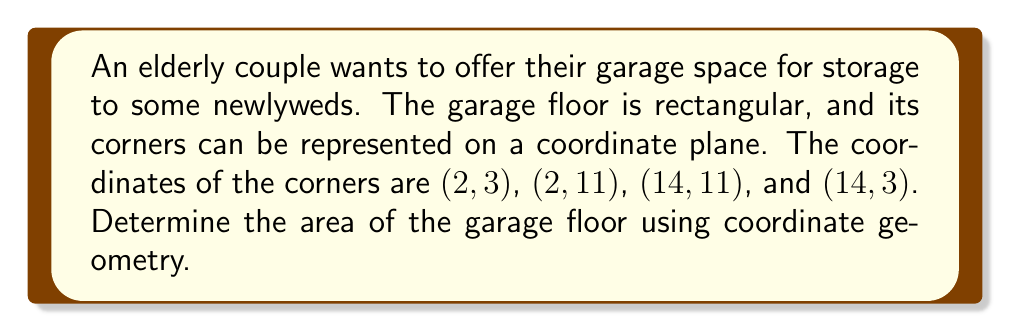Teach me how to tackle this problem. To solve this problem, we'll follow these steps:

1) First, we need to identify the length and width of the rectangle using the given coordinates.

2) The length of the rectangle is the distance between points with different x-coordinates:
   $$(14 - 2) = 12$$

3) The width of the rectangle is the distance between points with different y-coordinates:
   $$(11 - 3) = 8$$

4) We can visualize this using the following diagram:

[asy]
unitsize(0.5cm);
draw((2,3)--(14,3)--(14,11)--(2,11)--cycle);
label("(2, 3)", (2,3), SW);
label("(14, 3)", (14,3), SE);
label("(2, 11)", (2,11), NW);
label("(14, 11)", (14,11), NE);
label("12", (8,3), S);
label("8", (2,7), W);
[/asy]

5) The area of a rectangle is given by the formula:

   $$A = l \times w$$

   Where $A$ is the area, $l$ is the length, and $w$ is the width.

6) Substituting our values:

   $$A = 12 \times 8 = 96$$

Therefore, the area of the garage floor is 96 square units.
Answer: 96 square units 